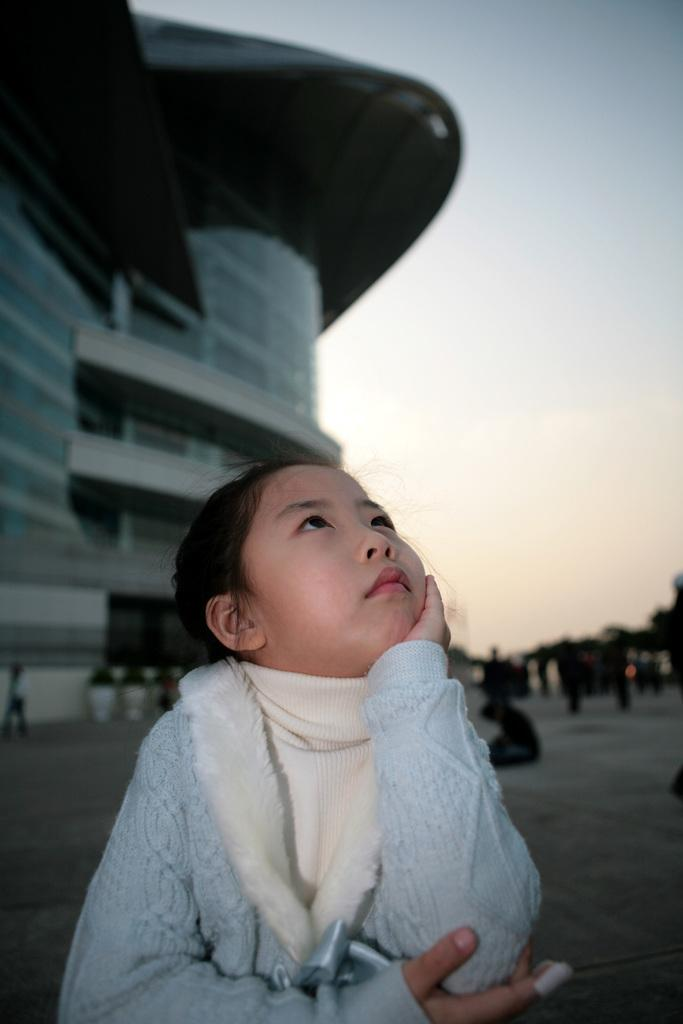What is the main subject of the image? There is a girl standing on the ground in the image. What can be seen in the background of the image? There is a building and the sky visible in the background of the image. How is the background of the image depicted? The background of the image is blurred. What type of jar is being discussed by the girl in the image? There is no jar or discussion present in the image; it features a girl standing on the ground with a blurred background. How many bricks can be seen in the image? There are no bricks visible in the image. 